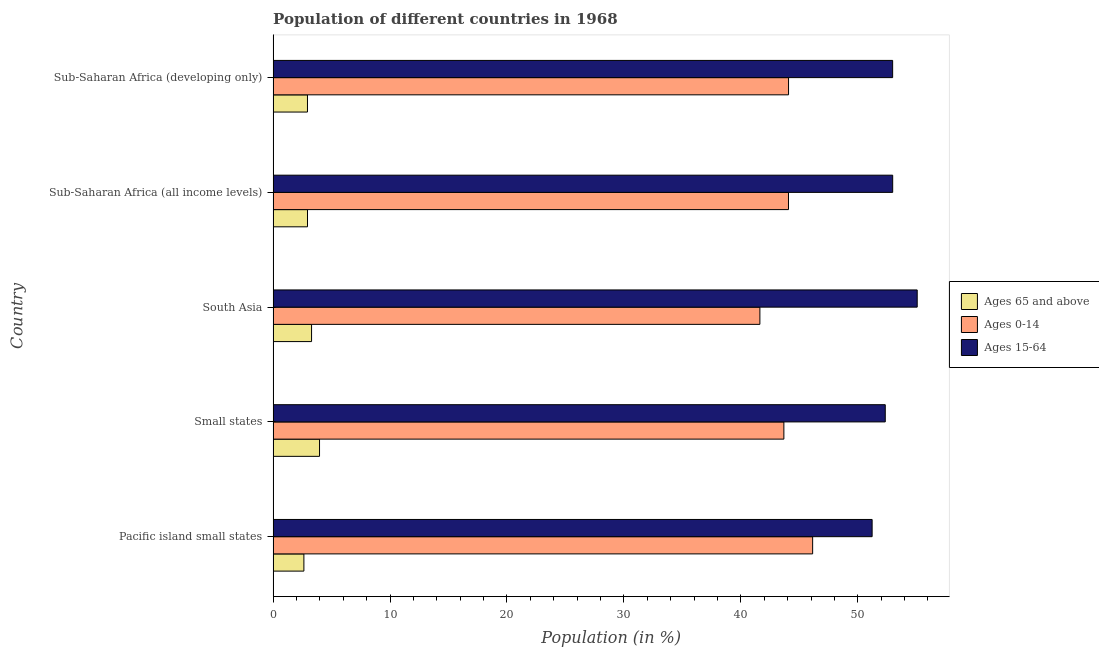How many different coloured bars are there?
Keep it short and to the point. 3. Are the number of bars on each tick of the Y-axis equal?
Your answer should be very brief. Yes. How many bars are there on the 1st tick from the bottom?
Provide a succinct answer. 3. What is the label of the 1st group of bars from the top?
Provide a succinct answer. Sub-Saharan Africa (developing only). In how many cases, is the number of bars for a given country not equal to the number of legend labels?
Your response must be concise. 0. What is the percentage of population within the age-group 0-14 in Sub-Saharan Africa (developing only)?
Make the answer very short. 44.08. Across all countries, what is the maximum percentage of population within the age-group of 65 and above?
Offer a terse response. 3.97. Across all countries, what is the minimum percentage of population within the age-group 0-14?
Your response must be concise. 41.63. In which country was the percentage of population within the age-group 0-14 maximum?
Offer a very short reply. Pacific island small states. In which country was the percentage of population within the age-group of 65 and above minimum?
Make the answer very short. Pacific island small states. What is the total percentage of population within the age-group 15-64 in the graph?
Your answer should be very brief. 264.63. What is the difference between the percentage of population within the age-group of 65 and above in South Asia and that in Sub-Saharan Africa (all income levels)?
Your response must be concise. 0.35. What is the difference between the percentage of population within the age-group of 65 and above in Small states and the percentage of population within the age-group 15-64 in Sub-Saharan Africa (all income levels)?
Provide a succinct answer. -49.02. What is the average percentage of population within the age-group 0-14 per country?
Ensure brevity in your answer.  43.92. What is the difference between the percentage of population within the age-group 15-64 and percentage of population within the age-group 0-14 in Small states?
Your response must be concise. 8.67. What is the ratio of the percentage of population within the age-group of 65 and above in Pacific island small states to that in Small states?
Offer a very short reply. 0.66. What is the difference between the highest and the second highest percentage of population within the age-group 0-14?
Offer a very short reply. 2.06. What is the difference between the highest and the lowest percentage of population within the age-group 15-64?
Make the answer very short. 3.86. Is the sum of the percentage of population within the age-group of 65 and above in Small states and Sub-Saharan Africa (developing only) greater than the maximum percentage of population within the age-group 0-14 across all countries?
Your answer should be compact. No. What does the 3rd bar from the top in Small states represents?
Give a very brief answer. Ages 65 and above. What does the 2nd bar from the bottom in Small states represents?
Ensure brevity in your answer.  Ages 0-14. How many countries are there in the graph?
Offer a terse response. 5. Are the values on the major ticks of X-axis written in scientific E-notation?
Your answer should be very brief. No. Does the graph contain any zero values?
Keep it short and to the point. No. How many legend labels are there?
Your answer should be compact. 3. How are the legend labels stacked?
Your answer should be very brief. Vertical. What is the title of the graph?
Give a very brief answer. Population of different countries in 1968. What is the label or title of the Y-axis?
Offer a very short reply. Country. What is the Population (in %) of Ages 65 and above in Pacific island small states?
Your answer should be compact. 2.63. What is the Population (in %) of Ages 0-14 in Pacific island small states?
Ensure brevity in your answer.  46.14. What is the Population (in %) in Ages 15-64 in Pacific island small states?
Your answer should be compact. 51.23. What is the Population (in %) in Ages 65 and above in Small states?
Your answer should be very brief. 3.97. What is the Population (in %) in Ages 0-14 in Small states?
Make the answer very short. 43.68. What is the Population (in %) in Ages 15-64 in Small states?
Your answer should be compact. 52.35. What is the Population (in %) of Ages 65 and above in South Asia?
Keep it short and to the point. 3.29. What is the Population (in %) in Ages 0-14 in South Asia?
Your response must be concise. 41.63. What is the Population (in %) of Ages 15-64 in South Asia?
Offer a terse response. 55.08. What is the Population (in %) in Ages 65 and above in Sub-Saharan Africa (all income levels)?
Give a very brief answer. 2.94. What is the Population (in %) in Ages 0-14 in Sub-Saharan Africa (all income levels)?
Ensure brevity in your answer.  44.07. What is the Population (in %) of Ages 15-64 in Sub-Saharan Africa (all income levels)?
Your response must be concise. 52.99. What is the Population (in %) in Ages 65 and above in Sub-Saharan Africa (developing only)?
Keep it short and to the point. 2.94. What is the Population (in %) of Ages 0-14 in Sub-Saharan Africa (developing only)?
Make the answer very short. 44.08. What is the Population (in %) of Ages 15-64 in Sub-Saharan Africa (developing only)?
Give a very brief answer. 52.98. Across all countries, what is the maximum Population (in %) in Ages 65 and above?
Offer a terse response. 3.97. Across all countries, what is the maximum Population (in %) of Ages 0-14?
Provide a short and direct response. 46.14. Across all countries, what is the maximum Population (in %) in Ages 15-64?
Provide a succinct answer. 55.08. Across all countries, what is the minimum Population (in %) in Ages 65 and above?
Offer a terse response. 2.63. Across all countries, what is the minimum Population (in %) in Ages 0-14?
Give a very brief answer. 41.63. Across all countries, what is the minimum Population (in %) in Ages 15-64?
Keep it short and to the point. 51.23. What is the total Population (in %) of Ages 65 and above in the graph?
Your answer should be very brief. 15.77. What is the total Population (in %) of Ages 0-14 in the graph?
Offer a terse response. 219.6. What is the total Population (in %) of Ages 15-64 in the graph?
Offer a terse response. 264.63. What is the difference between the Population (in %) in Ages 65 and above in Pacific island small states and that in Small states?
Ensure brevity in your answer.  -1.34. What is the difference between the Population (in %) in Ages 0-14 in Pacific island small states and that in Small states?
Provide a succinct answer. 2.46. What is the difference between the Population (in %) of Ages 15-64 in Pacific island small states and that in Small states?
Ensure brevity in your answer.  -1.12. What is the difference between the Population (in %) in Ages 65 and above in Pacific island small states and that in South Asia?
Offer a terse response. -0.66. What is the difference between the Population (in %) in Ages 0-14 in Pacific island small states and that in South Asia?
Offer a terse response. 4.51. What is the difference between the Population (in %) of Ages 15-64 in Pacific island small states and that in South Asia?
Provide a short and direct response. -3.86. What is the difference between the Population (in %) in Ages 65 and above in Pacific island small states and that in Sub-Saharan Africa (all income levels)?
Offer a terse response. -0.31. What is the difference between the Population (in %) in Ages 0-14 in Pacific island small states and that in Sub-Saharan Africa (all income levels)?
Your answer should be very brief. 2.07. What is the difference between the Population (in %) in Ages 15-64 in Pacific island small states and that in Sub-Saharan Africa (all income levels)?
Your answer should be very brief. -1.76. What is the difference between the Population (in %) in Ages 65 and above in Pacific island small states and that in Sub-Saharan Africa (developing only)?
Your response must be concise. -0.31. What is the difference between the Population (in %) in Ages 0-14 in Pacific island small states and that in Sub-Saharan Africa (developing only)?
Keep it short and to the point. 2.06. What is the difference between the Population (in %) of Ages 15-64 in Pacific island small states and that in Sub-Saharan Africa (developing only)?
Provide a succinct answer. -1.75. What is the difference between the Population (in %) of Ages 65 and above in Small states and that in South Asia?
Your answer should be compact. 0.68. What is the difference between the Population (in %) of Ages 0-14 in Small states and that in South Asia?
Your answer should be compact. 2.05. What is the difference between the Population (in %) in Ages 15-64 in Small states and that in South Asia?
Ensure brevity in your answer.  -2.73. What is the difference between the Population (in %) of Ages 65 and above in Small states and that in Sub-Saharan Africa (all income levels)?
Keep it short and to the point. 1.03. What is the difference between the Population (in %) in Ages 0-14 in Small states and that in Sub-Saharan Africa (all income levels)?
Keep it short and to the point. -0.39. What is the difference between the Population (in %) in Ages 15-64 in Small states and that in Sub-Saharan Africa (all income levels)?
Your answer should be very brief. -0.63. What is the difference between the Population (in %) of Ages 65 and above in Small states and that in Sub-Saharan Africa (developing only)?
Provide a succinct answer. 1.03. What is the difference between the Population (in %) of Ages 0-14 in Small states and that in Sub-Saharan Africa (developing only)?
Your answer should be very brief. -0.4. What is the difference between the Population (in %) in Ages 15-64 in Small states and that in Sub-Saharan Africa (developing only)?
Make the answer very short. -0.63. What is the difference between the Population (in %) in Ages 65 and above in South Asia and that in Sub-Saharan Africa (all income levels)?
Your answer should be compact. 0.35. What is the difference between the Population (in %) of Ages 0-14 in South Asia and that in Sub-Saharan Africa (all income levels)?
Keep it short and to the point. -2.44. What is the difference between the Population (in %) in Ages 15-64 in South Asia and that in Sub-Saharan Africa (all income levels)?
Your answer should be compact. 2.1. What is the difference between the Population (in %) of Ages 65 and above in South Asia and that in Sub-Saharan Africa (developing only)?
Your answer should be very brief. 0.35. What is the difference between the Population (in %) of Ages 0-14 in South Asia and that in Sub-Saharan Africa (developing only)?
Ensure brevity in your answer.  -2.45. What is the difference between the Population (in %) in Ages 15-64 in South Asia and that in Sub-Saharan Africa (developing only)?
Provide a short and direct response. 2.1. What is the difference between the Population (in %) in Ages 65 and above in Sub-Saharan Africa (all income levels) and that in Sub-Saharan Africa (developing only)?
Provide a succinct answer. 0. What is the difference between the Population (in %) of Ages 0-14 in Sub-Saharan Africa (all income levels) and that in Sub-Saharan Africa (developing only)?
Give a very brief answer. -0.01. What is the difference between the Population (in %) in Ages 15-64 in Sub-Saharan Africa (all income levels) and that in Sub-Saharan Africa (developing only)?
Your answer should be very brief. 0. What is the difference between the Population (in %) in Ages 65 and above in Pacific island small states and the Population (in %) in Ages 0-14 in Small states?
Ensure brevity in your answer.  -41.05. What is the difference between the Population (in %) in Ages 65 and above in Pacific island small states and the Population (in %) in Ages 15-64 in Small states?
Your response must be concise. -49.72. What is the difference between the Population (in %) in Ages 0-14 in Pacific island small states and the Population (in %) in Ages 15-64 in Small states?
Your answer should be compact. -6.21. What is the difference between the Population (in %) in Ages 65 and above in Pacific island small states and the Population (in %) in Ages 0-14 in South Asia?
Your answer should be compact. -39. What is the difference between the Population (in %) in Ages 65 and above in Pacific island small states and the Population (in %) in Ages 15-64 in South Asia?
Ensure brevity in your answer.  -52.45. What is the difference between the Population (in %) in Ages 0-14 in Pacific island small states and the Population (in %) in Ages 15-64 in South Asia?
Offer a terse response. -8.94. What is the difference between the Population (in %) in Ages 65 and above in Pacific island small states and the Population (in %) in Ages 0-14 in Sub-Saharan Africa (all income levels)?
Ensure brevity in your answer.  -41.44. What is the difference between the Population (in %) of Ages 65 and above in Pacific island small states and the Population (in %) of Ages 15-64 in Sub-Saharan Africa (all income levels)?
Offer a terse response. -50.35. What is the difference between the Population (in %) of Ages 0-14 in Pacific island small states and the Population (in %) of Ages 15-64 in Sub-Saharan Africa (all income levels)?
Ensure brevity in your answer.  -6.85. What is the difference between the Population (in %) in Ages 65 and above in Pacific island small states and the Population (in %) in Ages 0-14 in Sub-Saharan Africa (developing only)?
Your answer should be compact. -41.45. What is the difference between the Population (in %) in Ages 65 and above in Pacific island small states and the Population (in %) in Ages 15-64 in Sub-Saharan Africa (developing only)?
Provide a succinct answer. -50.35. What is the difference between the Population (in %) of Ages 0-14 in Pacific island small states and the Population (in %) of Ages 15-64 in Sub-Saharan Africa (developing only)?
Keep it short and to the point. -6.84. What is the difference between the Population (in %) in Ages 65 and above in Small states and the Population (in %) in Ages 0-14 in South Asia?
Offer a very short reply. -37.66. What is the difference between the Population (in %) of Ages 65 and above in Small states and the Population (in %) of Ages 15-64 in South Asia?
Offer a very short reply. -51.11. What is the difference between the Population (in %) in Ages 0-14 in Small states and the Population (in %) in Ages 15-64 in South Asia?
Ensure brevity in your answer.  -11.4. What is the difference between the Population (in %) of Ages 65 and above in Small states and the Population (in %) of Ages 0-14 in Sub-Saharan Africa (all income levels)?
Your answer should be very brief. -40.1. What is the difference between the Population (in %) in Ages 65 and above in Small states and the Population (in %) in Ages 15-64 in Sub-Saharan Africa (all income levels)?
Make the answer very short. -49.02. What is the difference between the Population (in %) in Ages 0-14 in Small states and the Population (in %) in Ages 15-64 in Sub-Saharan Africa (all income levels)?
Offer a very short reply. -9.31. What is the difference between the Population (in %) of Ages 65 and above in Small states and the Population (in %) of Ages 0-14 in Sub-Saharan Africa (developing only)?
Offer a terse response. -40.11. What is the difference between the Population (in %) of Ages 65 and above in Small states and the Population (in %) of Ages 15-64 in Sub-Saharan Africa (developing only)?
Your response must be concise. -49.01. What is the difference between the Population (in %) in Ages 0-14 in Small states and the Population (in %) in Ages 15-64 in Sub-Saharan Africa (developing only)?
Offer a very short reply. -9.3. What is the difference between the Population (in %) of Ages 65 and above in South Asia and the Population (in %) of Ages 0-14 in Sub-Saharan Africa (all income levels)?
Give a very brief answer. -40.79. What is the difference between the Population (in %) in Ages 65 and above in South Asia and the Population (in %) in Ages 15-64 in Sub-Saharan Africa (all income levels)?
Your response must be concise. -49.7. What is the difference between the Population (in %) in Ages 0-14 in South Asia and the Population (in %) in Ages 15-64 in Sub-Saharan Africa (all income levels)?
Ensure brevity in your answer.  -11.36. What is the difference between the Population (in %) of Ages 65 and above in South Asia and the Population (in %) of Ages 0-14 in Sub-Saharan Africa (developing only)?
Offer a terse response. -40.79. What is the difference between the Population (in %) of Ages 65 and above in South Asia and the Population (in %) of Ages 15-64 in Sub-Saharan Africa (developing only)?
Provide a succinct answer. -49.7. What is the difference between the Population (in %) of Ages 0-14 in South Asia and the Population (in %) of Ages 15-64 in Sub-Saharan Africa (developing only)?
Your answer should be very brief. -11.35. What is the difference between the Population (in %) in Ages 65 and above in Sub-Saharan Africa (all income levels) and the Population (in %) in Ages 0-14 in Sub-Saharan Africa (developing only)?
Your answer should be very brief. -41.14. What is the difference between the Population (in %) in Ages 65 and above in Sub-Saharan Africa (all income levels) and the Population (in %) in Ages 15-64 in Sub-Saharan Africa (developing only)?
Ensure brevity in your answer.  -50.04. What is the difference between the Population (in %) of Ages 0-14 in Sub-Saharan Africa (all income levels) and the Population (in %) of Ages 15-64 in Sub-Saharan Africa (developing only)?
Your response must be concise. -8.91. What is the average Population (in %) of Ages 65 and above per country?
Keep it short and to the point. 3.15. What is the average Population (in %) of Ages 0-14 per country?
Your response must be concise. 43.92. What is the average Population (in %) of Ages 15-64 per country?
Give a very brief answer. 52.93. What is the difference between the Population (in %) in Ages 65 and above and Population (in %) in Ages 0-14 in Pacific island small states?
Ensure brevity in your answer.  -43.51. What is the difference between the Population (in %) in Ages 65 and above and Population (in %) in Ages 15-64 in Pacific island small states?
Offer a very short reply. -48.6. What is the difference between the Population (in %) in Ages 0-14 and Population (in %) in Ages 15-64 in Pacific island small states?
Your answer should be very brief. -5.09. What is the difference between the Population (in %) of Ages 65 and above and Population (in %) of Ages 0-14 in Small states?
Offer a very short reply. -39.71. What is the difference between the Population (in %) in Ages 65 and above and Population (in %) in Ages 15-64 in Small states?
Keep it short and to the point. -48.38. What is the difference between the Population (in %) of Ages 0-14 and Population (in %) of Ages 15-64 in Small states?
Ensure brevity in your answer.  -8.67. What is the difference between the Population (in %) in Ages 65 and above and Population (in %) in Ages 0-14 in South Asia?
Your answer should be compact. -38.34. What is the difference between the Population (in %) of Ages 65 and above and Population (in %) of Ages 15-64 in South Asia?
Ensure brevity in your answer.  -51.8. What is the difference between the Population (in %) in Ages 0-14 and Population (in %) in Ages 15-64 in South Asia?
Offer a terse response. -13.45. What is the difference between the Population (in %) in Ages 65 and above and Population (in %) in Ages 0-14 in Sub-Saharan Africa (all income levels)?
Your answer should be compact. -41.13. What is the difference between the Population (in %) in Ages 65 and above and Population (in %) in Ages 15-64 in Sub-Saharan Africa (all income levels)?
Ensure brevity in your answer.  -50.05. What is the difference between the Population (in %) of Ages 0-14 and Population (in %) of Ages 15-64 in Sub-Saharan Africa (all income levels)?
Your answer should be very brief. -8.91. What is the difference between the Population (in %) of Ages 65 and above and Population (in %) of Ages 0-14 in Sub-Saharan Africa (developing only)?
Give a very brief answer. -41.14. What is the difference between the Population (in %) of Ages 65 and above and Population (in %) of Ages 15-64 in Sub-Saharan Africa (developing only)?
Make the answer very short. -50.04. What is the difference between the Population (in %) of Ages 0-14 and Population (in %) of Ages 15-64 in Sub-Saharan Africa (developing only)?
Offer a very short reply. -8.9. What is the ratio of the Population (in %) of Ages 65 and above in Pacific island small states to that in Small states?
Offer a terse response. 0.66. What is the ratio of the Population (in %) of Ages 0-14 in Pacific island small states to that in Small states?
Your response must be concise. 1.06. What is the ratio of the Population (in %) of Ages 15-64 in Pacific island small states to that in Small states?
Offer a very short reply. 0.98. What is the ratio of the Population (in %) in Ages 65 and above in Pacific island small states to that in South Asia?
Offer a terse response. 0.8. What is the ratio of the Population (in %) of Ages 0-14 in Pacific island small states to that in South Asia?
Offer a very short reply. 1.11. What is the ratio of the Population (in %) of Ages 15-64 in Pacific island small states to that in South Asia?
Your response must be concise. 0.93. What is the ratio of the Population (in %) of Ages 65 and above in Pacific island small states to that in Sub-Saharan Africa (all income levels)?
Offer a terse response. 0.9. What is the ratio of the Population (in %) of Ages 0-14 in Pacific island small states to that in Sub-Saharan Africa (all income levels)?
Make the answer very short. 1.05. What is the ratio of the Population (in %) in Ages 15-64 in Pacific island small states to that in Sub-Saharan Africa (all income levels)?
Give a very brief answer. 0.97. What is the ratio of the Population (in %) of Ages 65 and above in Pacific island small states to that in Sub-Saharan Africa (developing only)?
Give a very brief answer. 0.9. What is the ratio of the Population (in %) in Ages 0-14 in Pacific island small states to that in Sub-Saharan Africa (developing only)?
Your answer should be very brief. 1.05. What is the ratio of the Population (in %) of Ages 15-64 in Pacific island small states to that in Sub-Saharan Africa (developing only)?
Make the answer very short. 0.97. What is the ratio of the Population (in %) of Ages 65 and above in Small states to that in South Asia?
Give a very brief answer. 1.21. What is the ratio of the Population (in %) of Ages 0-14 in Small states to that in South Asia?
Offer a terse response. 1.05. What is the ratio of the Population (in %) of Ages 15-64 in Small states to that in South Asia?
Your answer should be very brief. 0.95. What is the ratio of the Population (in %) of Ages 65 and above in Small states to that in Sub-Saharan Africa (all income levels)?
Provide a succinct answer. 1.35. What is the ratio of the Population (in %) in Ages 15-64 in Small states to that in Sub-Saharan Africa (all income levels)?
Make the answer very short. 0.99. What is the ratio of the Population (in %) in Ages 65 and above in Small states to that in Sub-Saharan Africa (developing only)?
Give a very brief answer. 1.35. What is the ratio of the Population (in %) in Ages 0-14 in Small states to that in Sub-Saharan Africa (developing only)?
Provide a short and direct response. 0.99. What is the ratio of the Population (in %) of Ages 65 and above in South Asia to that in Sub-Saharan Africa (all income levels)?
Your answer should be very brief. 1.12. What is the ratio of the Population (in %) in Ages 0-14 in South Asia to that in Sub-Saharan Africa (all income levels)?
Your answer should be very brief. 0.94. What is the ratio of the Population (in %) of Ages 15-64 in South Asia to that in Sub-Saharan Africa (all income levels)?
Provide a succinct answer. 1.04. What is the ratio of the Population (in %) of Ages 65 and above in South Asia to that in Sub-Saharan Africa (developing only)?
Make the answer very short. 1.12. What is the ratio of the Population (in %) of Ages 15-64 in South Asia to that in Sub-Saharan Africa (developing only)?
Ensure brevity in your answer.  1.04. What is the ratio of the Population (in %) in Ages 65 and above in Sub-Saharan Africa (all income levels) to that in Sub-Saharan Africa (developing only)?
Provide a succinct answer. 1. What is the ratio of the Population (in %) of Ages 0-14 in Sub-Saharan Africa (all income levels) to that in Sub-Saharan Africa (developing only)?
Offer a very short reply. 1. What is the ratio of the Population (in %) in Ages 15-64 in Sub-Saharan Africa (all income levels) to that in Sub-Saharan Africa (developing only)?
Offer a very short reply. 1. What is the difference between the highest and the second highest Population (in %) in Ages 65 and above?
Offer a terse response. 0.68. What is the difference between the highest and the second highest Population (in %) in Ages 0-14?
Offer a terse response. 2.06. What is the difference between the highest and the second highest Population (in %) in Ages 15-64?
Provide a succinct answer. 2.1. What is the difference between the highest and the lowest Population (in %) of Ages 65 and above?
Ensure brevity in your answer.  1.34. What is the difference between the highest and the lowest Population (in %) of Ages 0-14?
Your answer should be very brief. 4.51. What is the difference between the highest and the lowest Population (in %) of Ages 15-64?
Ensure brevity in your answer.  3.86. 